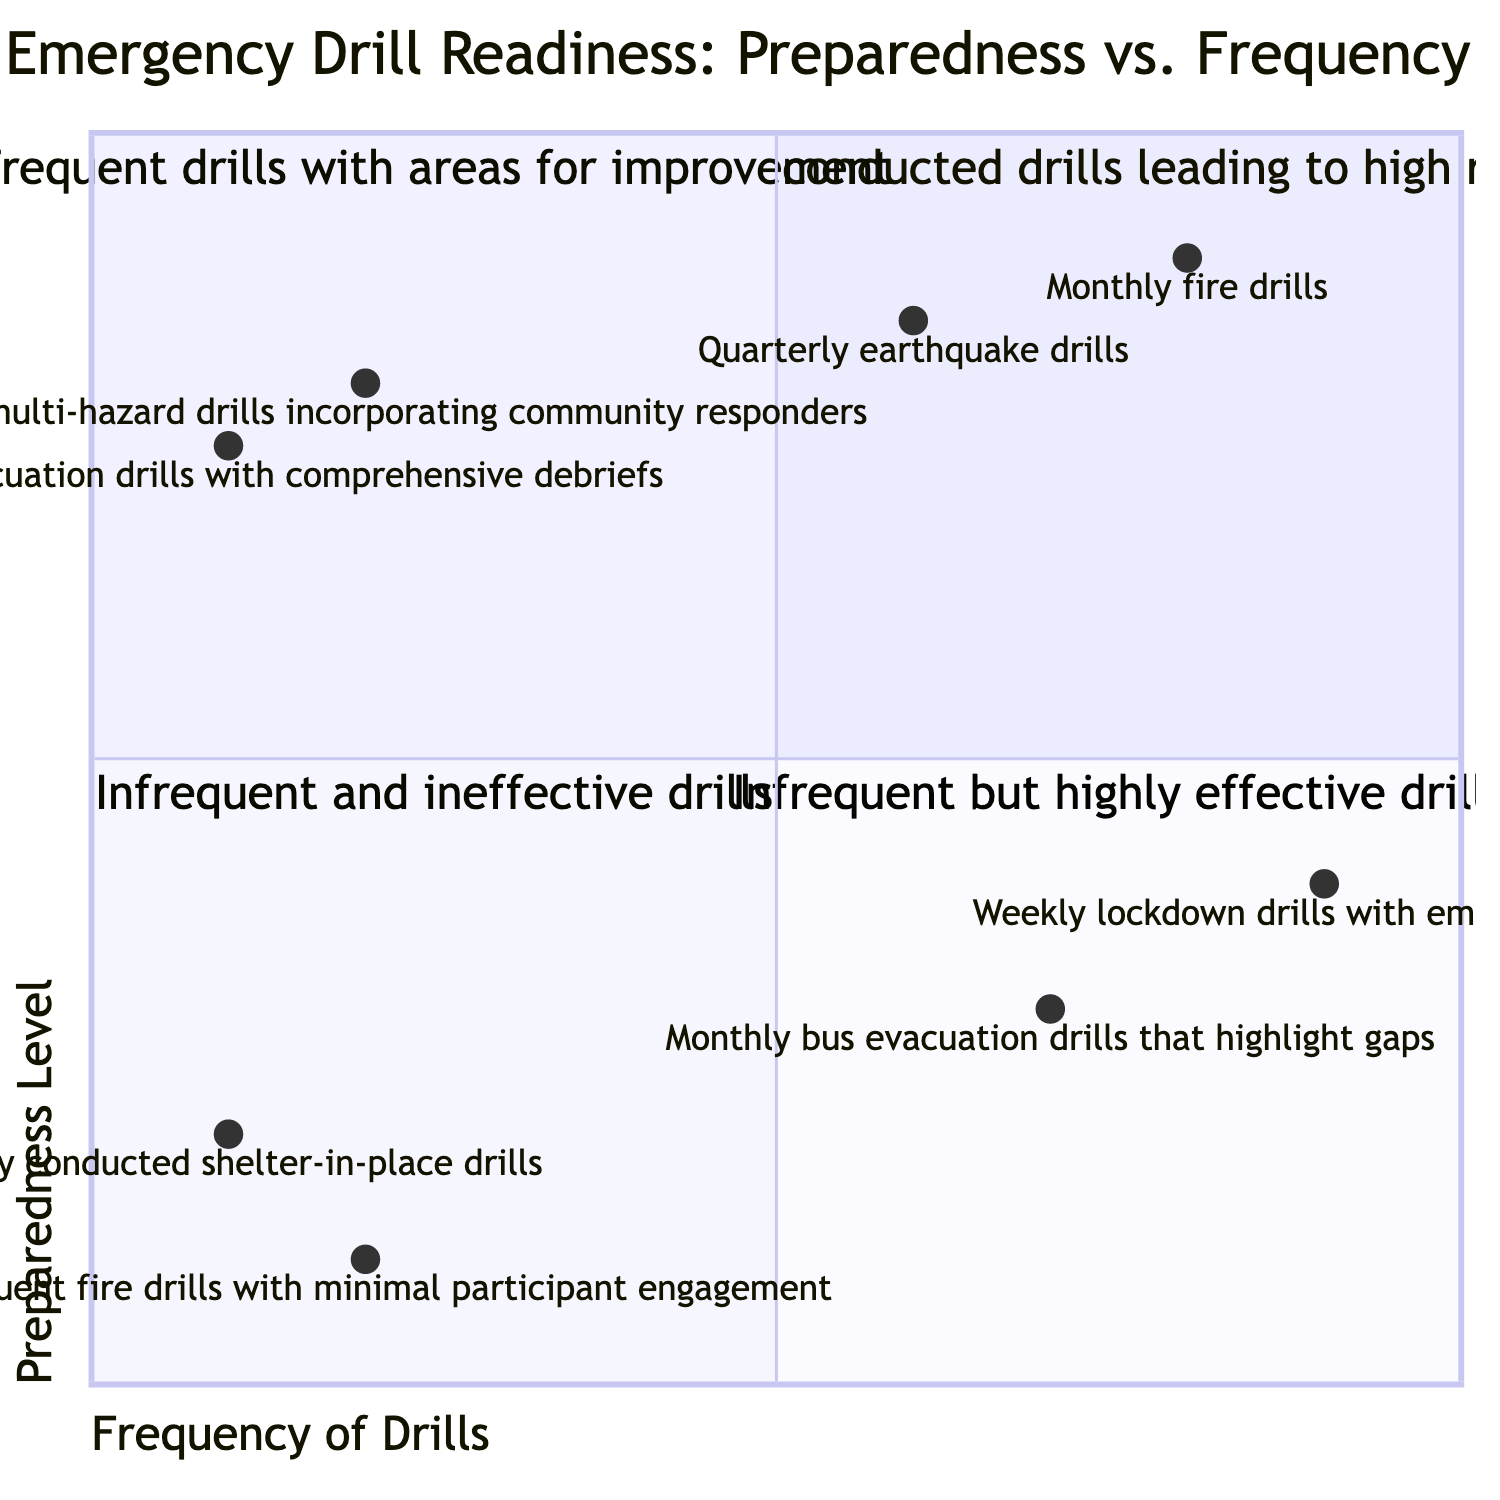What are the examples of drills in the High Frequency, High Preparedness quadrant? The High Frequency, High Preparedness quadrant contains examples such as "Monthly fire drills" and "Quarterly earthquake drills."
Answer: Monthly fire drills, Quarterly earthquake drills How many examples are provided in the Low Frequency, Low Preparedness quadrant? The Low Frequency, Low Preparedness quadrant has two examples: "Rarely conducted shelter-in-place drills" and "Infrequent fire drills with minimal participant engagement." Thus, the count is 2.
Answer: 2 Which quadrant contains the Weekly lockdown drills with emerging issues? The Weekly lockdown drills with emerging issues are located in the High Frequency, Low Preparedness quadrant, where frequent drills occur but there are areas for improvement.
Answer: High Frequency, Low Preparedness What is the preparedness level of the Annual multi-hazard drills incorporating community responders? The preparedness level of the Annual multi-hazard drills incorporating community responders is indicated on the diagram as 0.8.
Answer: 0.8 Which frequency category has the least effective drills according to the diagram? The Low Frequency, Low Preparedness quadrant contains the least effective drills, as they are both infrequent and ineffective.
Answer: Low Frequency, Low Preparedness How does the preparedness level of Monthly bus evacuation drills compare to that of Quarterly earthquake drills? The Monthly bus evacuation drills have a preparedness level of 0.3, while the Quarterly earthquake drills have a preparedness level of 0.85. This indicates that the latter is significantly higher than the former.
Answer: Higher for Quarterly earthquake drills Which quadrant is represented by infrequent but highly effective drills? The Low Frequency, High Preparedness quadrant is characterized by infrequent but highly effective drills, highlighting a unique readiness despite their lower frequency.
Answer: Low Frequency, High Preparedness What is the relationship between the frequency and preparedness level of infrequent fire drills? Infrequent fire drills fall into the Low Frequency, Low Preparedness quadrant, suggesting a direct correlation that both aspects (frequency and preparedness) are low.
Answer: Low Frequency, Low Preparedness How often are the drills in the High Frequency, High Preparedness quadrant conducted? Drills in the High Frequency, High Preparedness quadrant are conducted regularly, indicated by examples like "Monthly fire drills" and "Quarterly earthquake drills."
Answer: Regularly 